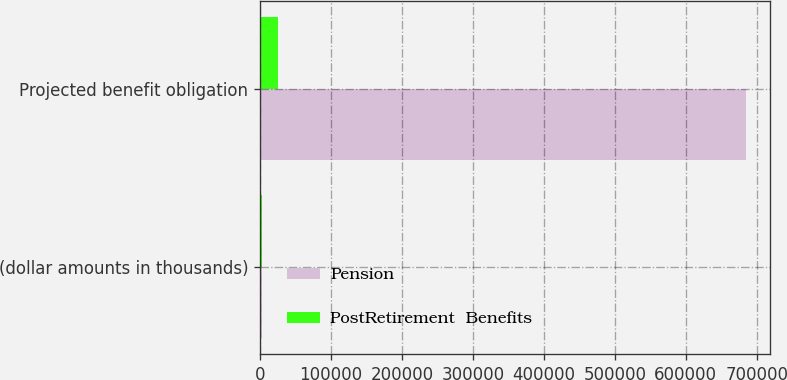<chart> <loc_0><loc_0><loc_500><loc_500><stacked_bar_chart><ecel><fcel>(dollar amounts in thousands)<fcel>Projected benefit obligation<nl><fcel>Pension<fcel>2013<fcel>684999<nl><fcel>PostRetirement  Benefits<fcel>2013<fcel>25669<nl></chart> 